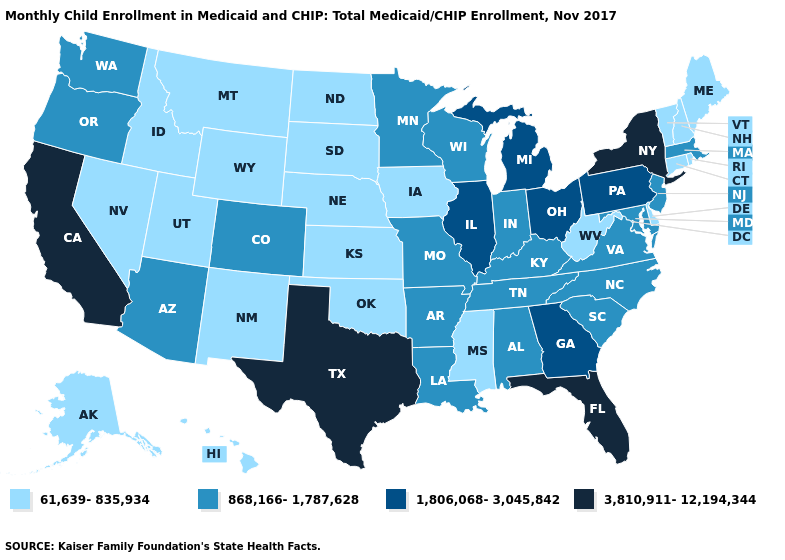Name the states that have a value in the range 61,639-835,934?
Be succinct. Alaska, Connecticut, Delaware, Hawaii, Idaho, Iowa, Kansas, Maine, Mississippi, Montana, Nebraska, Nevada, New Hampshire, New Mexico, North Dakota, Oklahoma, Rhode Island, South Dakota, Utah, Vermont, West Virginia, Wyoming. Name the states that have a value in the range 3,810,911-12,194,344?
Short answer required. California, Florida, New York, Texas. Among the states that border North Dakota , does South Dakota have the lowest value?
Be succinct. Yes. Name the states that have a value in the range 61,639-835,934?
Be succinct. Alaska, Connecticut, Delaware, Hawaii, Idaho, Iowa, Kansas, Maine, Mississippi, Montana, Nebraska, Nevada, New Hampshire, New Mexico, North Dakota, Oklahoma, Rhode Island, South Dakota, Utah, Vermont, West Virginia, Wyoming. Does the first symbol in the legend represent the smallest category?
Give a very brief answer. Yes. Name the states that have a value in the range 868,166-1,787,628?
Be succinct. Alabama, Arizona, Arkansas, Colorado, Indiana, Kentucky, Louisiana, Maryland, Massachusetts, Minnesota, Missouri, New Jersey, North Carolina, Oregon, South Carolina, Tennessee, Virginia, Washington, Wisconsin. What is the lowest value in the West?
Give a very brief answer. 61,639-835,934. Name the states that have a value in the range 61,639-835,934?
Give a very brief answer. Alaska, Connecticut, Delaware, Hawaii, Idaho, Iowa, Kansas, Maine, Mississippi, Montana, Nebraska, Nevada, New Hampshire, New Mexico, North Dakota, Oklahoma, Rhode Island, South Dakota, Utah, Vermont, West Virginia, Wyoming. Which states have the highest value in the USA?
Give a very brief answer. California, Florida, New York, Texas. Does Iowa have a lower value than Kentucky?
Write a very short answer. Yes. Name the states that have a value in the range 61,639-835,934?
Be succinct. Alaska, Connecticut, Delaware, Hawaii, Idaho, Iowa, Kansas, Maine, Mississippi, Montana, Nebraska, Nevada, New Hampshire, New Mexico, North Dakota, Oklahoma, Rhode Island, South Dakota, Utah, Vermont, West Virginia, Wyoming. Among the states that border Georgia , does Florida have the highest value?
Give a very brief answer. Yes. What is the value of South Carolina?
Answer briefly. 868,166-1,787,628. Which states hav the highest value in the West?
Short answer required. California. What is the value of Maine?
Quick response, please. 61,639-835,934. 